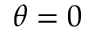<formula> <loc_0><loc_0><loc_500><loc_500>\theta = 0</formula> 